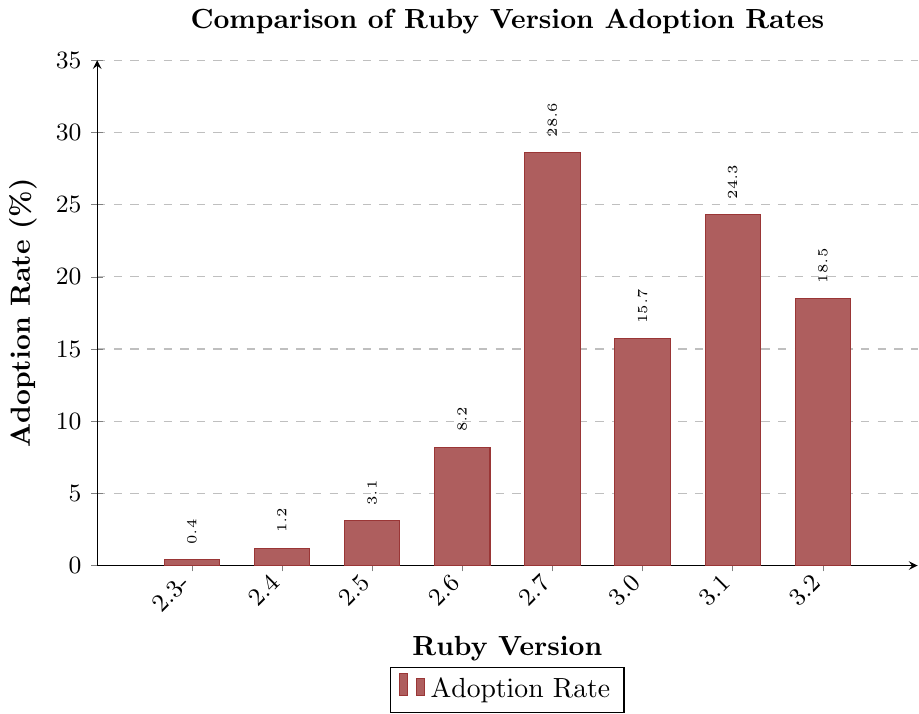Which Ruby version has the highest adoption rate? The tallest bar in the chart corresponds to Ruby 2.7, meaning it has the highest adoption rate.
Answer: Ruby 2.7 What is the combined adoption rate of Ruby 3.0 and Ruby 3.1? The adoption rate for Ruby 3.0 is 15.7%, and for Ruby 3.1, it is 24.3%. Adding these together gives 15.7% + 24.3% = 40.0%.
Answer: 40.0% How does the adoption rate of Ruby 2.7 compare to that of Ruby 3.2? Ruby 2.7 has an adoption rate of 28.6% which is higher than Ruby 3.2's adoption rate of 18.5%.
Answer: Ruby 2.7 has a higher rate Which Ruby version has the lowest adoption rate? The shortest bar in the chart corresponds to Ruby 2.3 or older, indicating it has the lowest adoption rate.
Answer: Ruby 2.3 or older What's the average adoption rate of Ruby versions 2.6 and older? Summing the adoption rates for versions 2.3 or older (0.4%), 2.4 (1.2%), 2.5 (3.1%), and 2.6 (8.2%) gives 0.4% + 1.2% + 3.1% + 8.2% = 12.9%. There are 4 versions, so the average is 12.9% / 4 = 3.225%.
Answer: 3.225% By how much does the adoption rate of Ruby 2.7 exceed that of Ruby 3.0? Ruby 2.7 has an adoption rate of 28.6%, and Ruby 3.0 has an adoption rate of 15.7%. The difference is 28.6% - 15.7% = 12.9%.
Answer: 12.9% What is the total adoption rate for all Ruby versions listed in the chart? The sum of all adoption rates is 0.4% + 1.2% + 3.1% + 8.2% + 28.6% + 15.7% + 24.3% + 18.5% = 100%.
Answer: 100% Which two Ruby versions have the closest adoption rates? The adoption rates for Ruby 3.0 (15.7%) and Ruby 3.2 (18.5%) have a difference of 2.8%, making them the closest.
Answer: Ruby 3.0 and Ruby 3.2 Is the adoption rate of Ruby 2.6 greater or less than half of Ruby 2.7's adoption rate? Half of Ruby 2.7's adoption rate is 28.6% / 2 = 14.3%. Ruby 2.6 has an adoption rate of 8.2%, which is less than 14.3%.
Answer: Less 